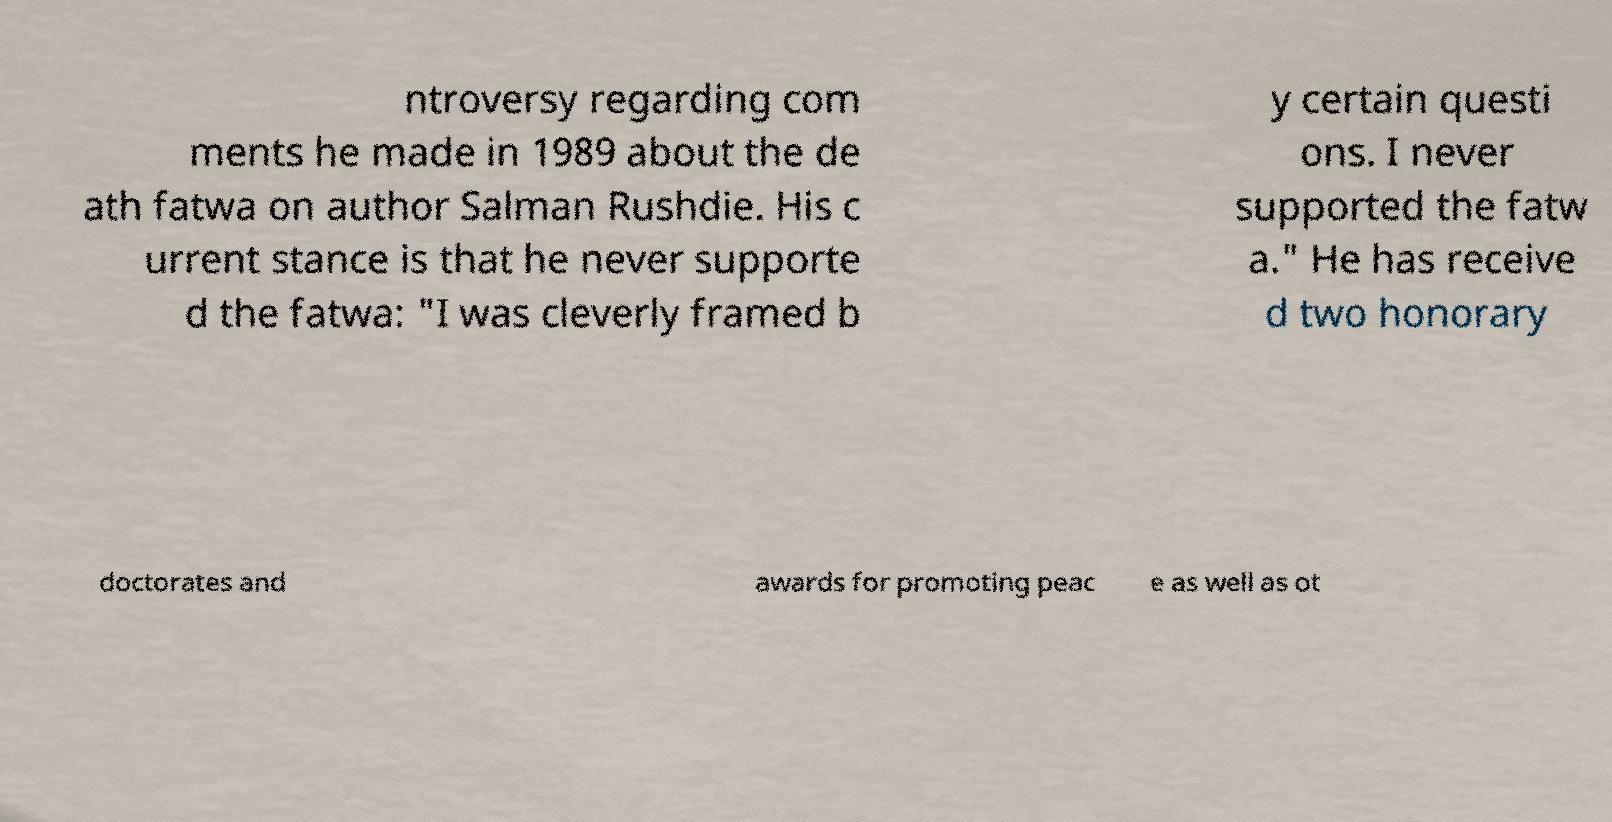I need the written content from this picture converted into text. Can you do that? ntroversy regarding com ments he made in 1989 about the de ath fatwa on author Salman Rushdie. His c urrent stance is that he never supporte d the fatwa: "I was cleverly framed b y certain questi ons. I never supported the fatw a." He has receive d two honorary doctorates and awards for promoting peac e as well as ot 